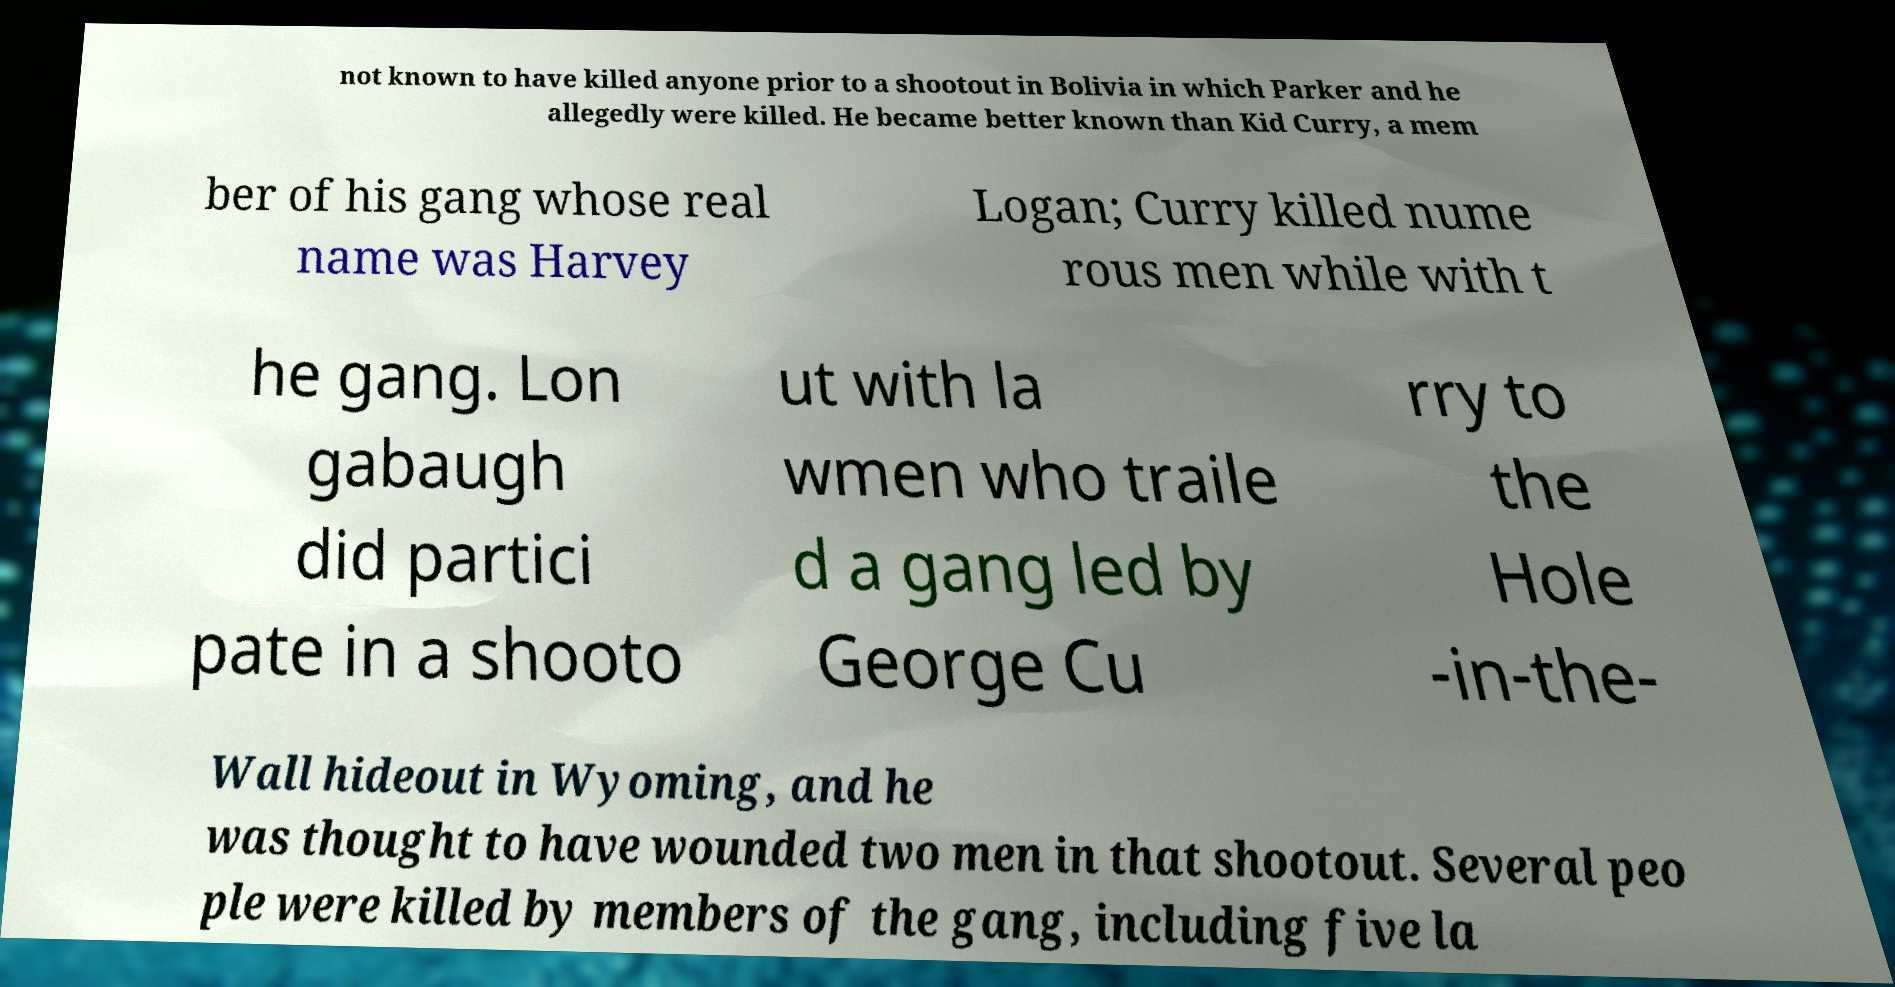Can you read and provide the text displayed in the image?This photo seems to have some interesting text. Can you extract and type it out for me? not known to have killed anyone prior to a shootout in Bolivia in which Parker and he allegedly were killed. He became better known than Kid Curry, a mem ber of his gang whose real name was Harvey Logan; Curry killed nume rous men while with t he gang. Lon gabaugh did partici pate in a shooto ut with la wmen who traile d a gang led by George Cu rry to the Hole -in-the- Wall hideout in Wyoming, and he was thought to have wounded two men in that shootout. Several peo ple were killed by members of the gang, including five la 